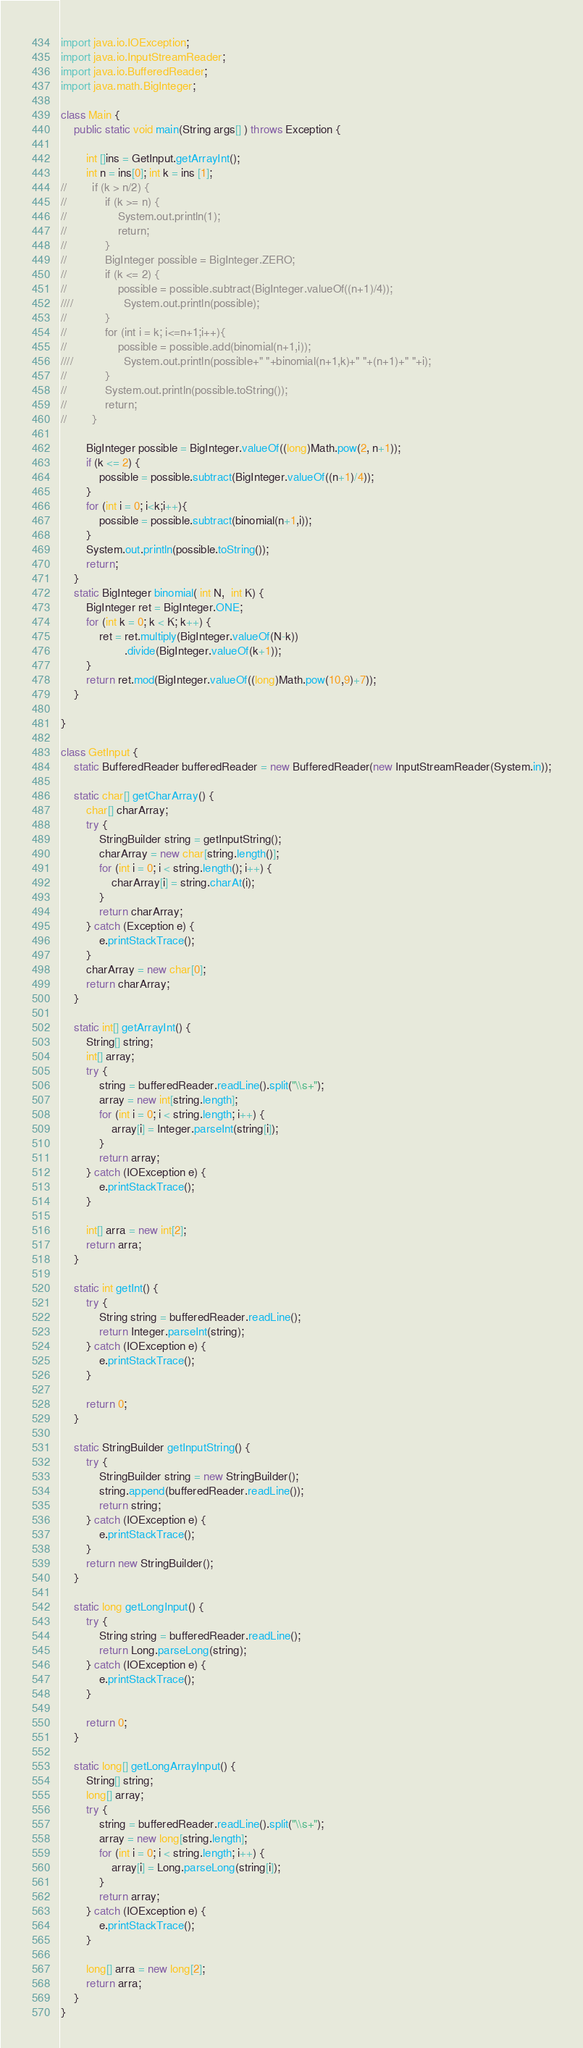Convert code to text. <code><loc_0><loc_0><loc_500><loc_500><_Java_>import java.io.IOException;
import java.io.InputStreamReader;
import java.io.BufferedReader;
import java.math.BigInteger;

class Main {
    public static void main(String args[] ) throws Exception {

        int []ins = GetInput.getArrayInt();
        int n = ins[0]; int k = ins [1];
//        if (k > n/2) {
//            if (k >= n) {
//                System.out.println(1);
//                return;
//            }
//            BigInteger possible = BigInteger.ZERO;
//            if (k <= 2) {
//                possible = possible.subtract(BigInteger.valueOf((n+1)/4));
////                System.out.println(possible);
//            }
//            for (int i = k; i<=n+1;i++){
//                possible = possible.add(binomial(n+1,i));
////                System.out.println(possible+" "+binomial(n+1,k)+" "+(n+1)+" "+i);
//            }
//            System.out.println(possible.toString());
//            return;
//        }

        BigInteger possible = BigInteger.valueOf((long)Math.pow(2, n+1));
        if (k <= 2) {
            possible = possible.subtract(BigInteger.valueOf((n+1)/4));
        }
        for (int i = 0; i<k;i++){
            possible = possible.subtract(binomial(n+1,i));
        }
        System.out.println(possible.toString());
        return;
    }
    static BigInteger binomial( int N,  int K) {
        BigInteger ret = BigInteger.ONE;
        for (int k = 0; k < K; k++) {
            ret = ret.multiply(BigInteger.valueOf(N-k))
                    .divide(BigInteger.valueOf(k+1));
        }
        return ret.mod(BigInteger.valueOf((long)Math.pow(10,9)+7));
    }

}

class GetInput {
    static BufferedReader bufferedReader = new BufferedReader(new InputStreamReader(System.in));

    static char[] getCharArray() {
        char[] charArray;
        try {
            StringBuilder string = getInputString();
            charArray = new char[string.length()];
            for (int i = 0; i < string.length(); i++) {
                charArray[i] = string.charAt(i);
            }
            return charArray;
        } catch (Exception e) {
            e.printStackTrace();
        }
        charArray = new char[0];
        return charArray;
    }

    static int[] getArrayInt() {
        String[] string;
        int[] array;
        try {
            string = bufferedReader.readLine().split("\\s+");
            array = new int[string.length];
            for (int i = 0; i < string.length; i++) {
                array[i] = Integer.parseInt(string[i]);
            }
            return array;
        } catch (IOException e) {
            e.printStackTrace();
        }

        int[] arra = new int[2];
        return arra;
    }

    static int getInt() {
        try {
            String string = bufferedReader.readLine();
            return Integer.parseInt(string);
        } catch (IOException e) {
            e.printStackTrace();
        }

        return 0;
    }

    static StringBuilder getInputString() {
        try {
            StringBuilder string = new StringBuilder();
            string.append(bufferedReader.readLine());
            return string;
        } catch (IOException e) {
            e.printStackTrace();
        }
        return new StringBuilder();
    }

    static long getLongInput() {
        try {
            String string = bufferedReader.readLine();
            return Long.parseLong(string);
        } catch (IOException e) {
            e.printStackTrace();
        }

        return 0;
    }

    static long[] getLongArrayInput() {
        String[] string;
        long[] array;
        try {
            string = bufferedReader.readLine().split("\\s+");
            array = new long[string.length];
            for (int i = 0; i < string.length; i++) {
                array[i] = Long.parseLong(string[i]);
            }
            return array;
        } catch (IOException e) {
            e.printStackTrace();
        }

        long[] arra = new long[2];
        return arra;
    }
}

</code> 